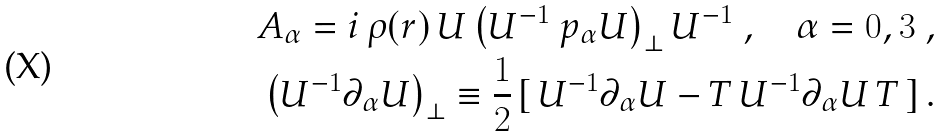Convert formula to latex. <formula><loc_0><loc_0><loc_500><loc_500>A _ { \alpha } = i \, \rho ( r ) \, U \left ( U ^ { - 1 } \ p _ { \alpha } U \right ) _ { \perp } U ^ { - 1 } \ , \quad \alpha = 0 , 3 \ , \\ \left ( U ^ { - 1 } \partial _ { \alpha } U \right ) _ { \perp } \equiv \frac { 1 } { 2 } \, [ \, U ^ { - 1 } \partial _ { \alpha } U - T \, U ^ { - 1 } \partial _ { \alpha } U \, T \, ] \, .</formula> 